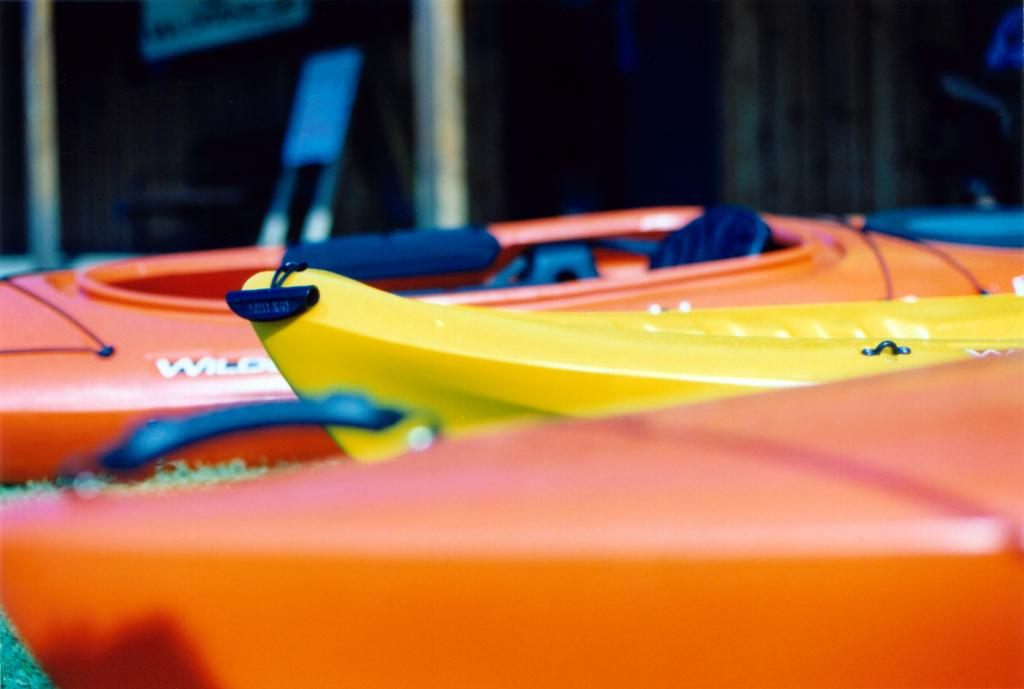What is the main subject of the image? The main subject of the image is a group of boats. Where are the boats located in the image? The boats are placed on the ground. What can be seen in the background of the image? There is a building and a board with text in the background of the image. What type of liquid is being taught by the pest in the image? There is no liquid, teaching, or pest present in the image. 